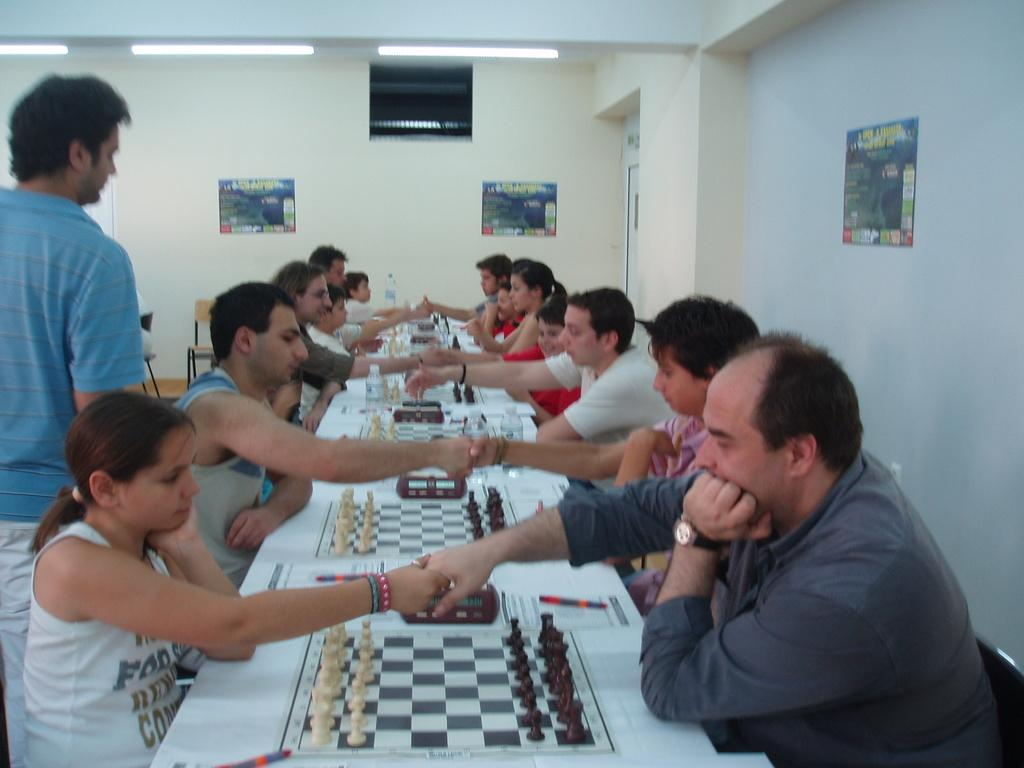What are the people in the image doing? The people in the image are playing chess. How are the people positioned while playing chess? They are sitting on chairs. Can you describe the background of the image? There is a man standing in the background and a poster on the wall. What can be seen in the image that provides light? There is a light visible in the image. What type of trail can be seen in the image? There is no trail present in the image. Is there a crown visible on any of the chess pieces in the image? The image does not show any crowns on the chess pieces; it only shows the standard chess pieces. 